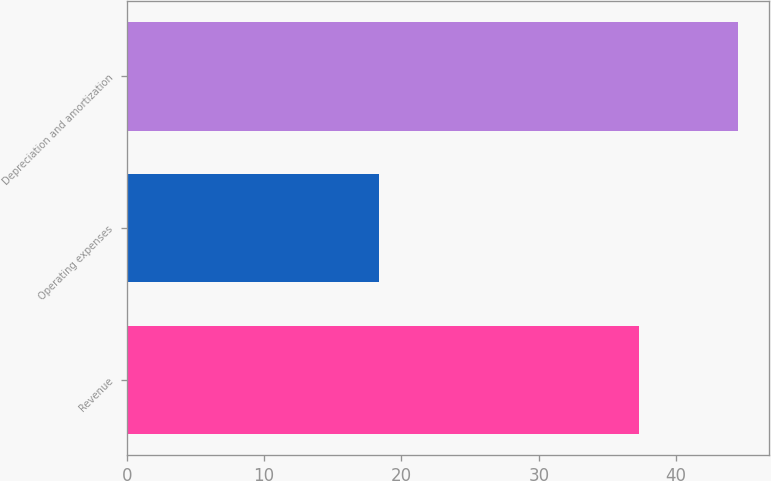Convert chart. <chart><loc_0><loc_0><loc_500><loc_500><bar_chart><fcel>Revenue<fcel>Operating expenses<fcel>Depreciation and amortization<nl><fcel>37.3<fcel>18.4<fcel>44.5<nl></chart> 